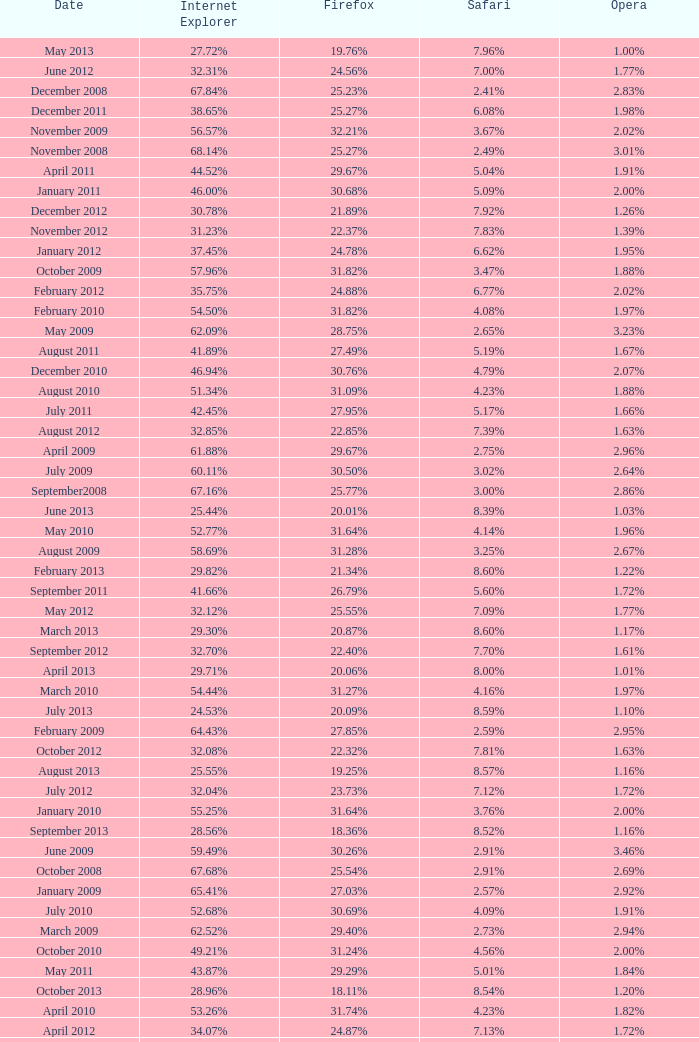What percentage of browsers were using Internet Explorer in April 2009? 61.88%. 